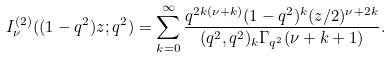Convert formula to latex. <formula><loc_0><loc_0><loc_500><loc_500>I _ { \nu } ^ { ( 2 ) } ( ( 1 - q ^ { 2 } ) z ; q ^ { 2 } ) = \sum _ { k = 0 } ^ { \infty } \frac { q ^ { 2 k ( \nu + k ) } ( 1 - q ^ { 2 } ) ^ { k } ( z / 2 ) ^ { \nu + 2 k } } { ( q ^ { 2 } , q ^ { 2 } ) _ { k } \Gamma _ { q ^ { 2 } } ( \nu + k + 1 ) } .</formula> 